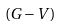<formula> <loc_0><loc_0><loc_500><loc_500>\left ( { G - V } \right )</formula> 